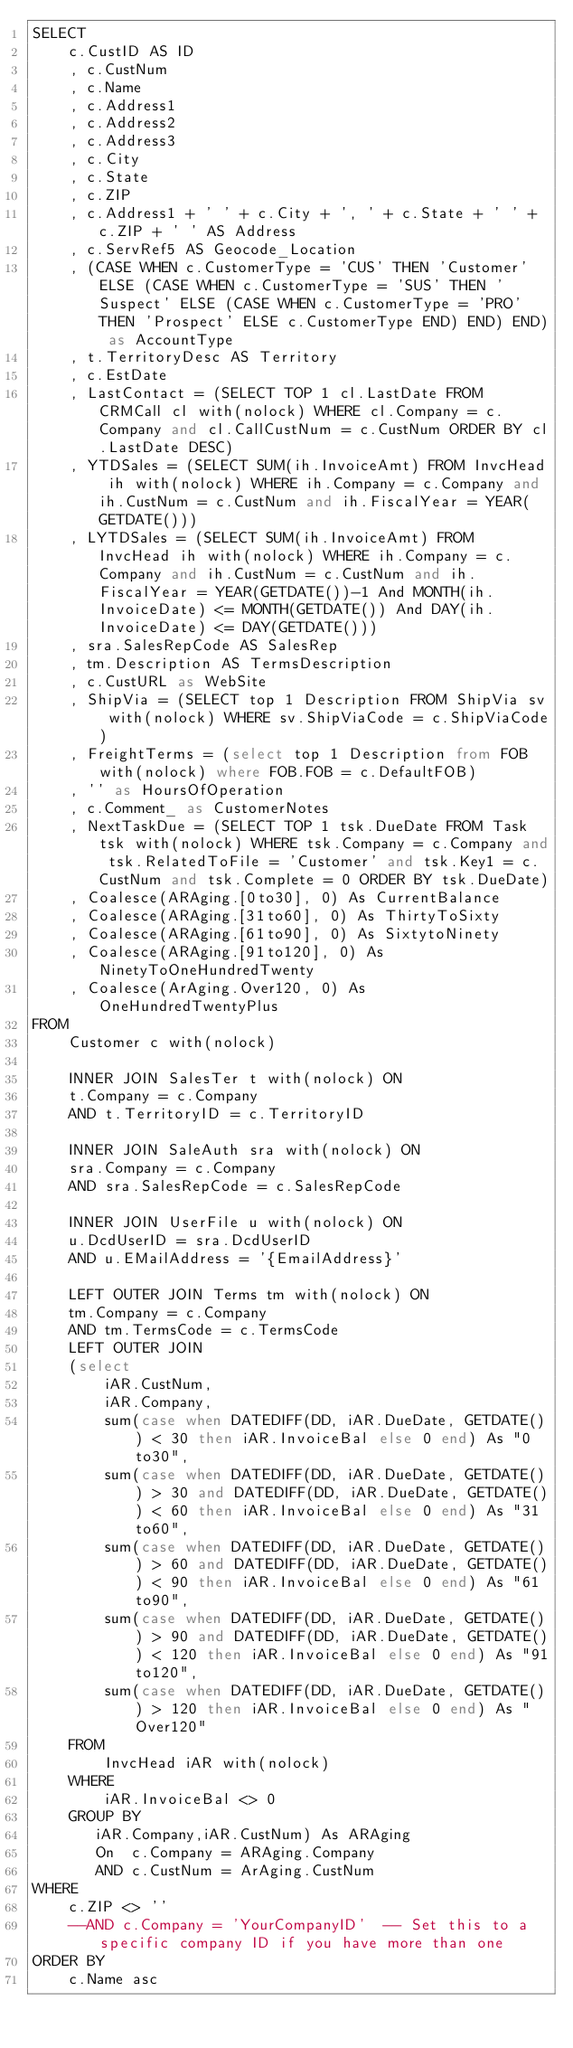<code> <loc_0><loc_0><loc_500><loc_500><_SQL_>SELECT
	c.CustID AS ID
	, c.CustNum
	, c.Name
	, c.Address1
	, c.Address2
	, c.Address3
	, c.City
	, c.State
	, c.ZIP
	, c.Address1 + ' ' + c.City + ', ' + c.State + ' ' + c.ZIP + ' ' AS Address
	, c.ServRef5 AS Geocode_Location
	, (CASE WHEN c.CustomerType = 'CUS' THEN 'Customer' ELSE (CASE WHEN c.CustomerType = 'SUS' THEN 'Suspect' ELSE (CASE WHEN c.CustomerType = 'PRO' THEN 'Prospect' ELSE c.CustomerType END) END) END) as AccountType
	, t.TerritoryDesc AS Territory
	, c.EstDate
	, LastContact = (SELECT TOP 1 cl.LastDate FROM CRMCall cl with(nolock) WHERE cl.Company = c.Company and cl.CallCustNum = c.CustNum ORDER BY cl.LastDate DESC)
	, YTDSales = (SELECT SUM(ih.InvoiceAmt) FROM InvcHead ih with(nolock) WHERE ih.Company = c.Company and ih.CustNum = c.CustNum and ih.FiscalYear = YEAR(GETDATE()))
	, LYTDSales = (SELECT SUM(ih.InvoiceAmt) FROM InvcHead ih with(nolock) WHERE ih.Company = c.Company and ih.CustNum = c.CustNum and ih.FiscalYear = YEAR(GETDATE())-1 And MONTH(ih.InvoiceDate) <= MONTH(GETDATE()) And DAY(ih.InvoiceDate) <= DAY(GETDATE()))
	, sra.SalesRepCode AS SalesRep
	, tm.Description AS TermsDescription
	, c.CustURL as WebSite
	, ShipVia = (SELECT top 1 Description FROM ShipVia sv with(nolock) WHERE sv.ShipViaCode = c.ShipViaCode)
	, FreightTerms = (select top 1 Description from FOB with(nolock) where FOB.FOB = c.DefaultFOB)
	, '' as HoursOfOperation
	, c.Comment_ as CustomerNotes
	, NextTaskDue = (SELECT TOP 1 tsk.DueDate FROM Task tsk with(nolock) WHERE tsk.Company = c.Company and tsk.RelatedToFile = 'Customer' and tsk.Key1 = c.CustNum and tsk.Complete = 0 ORDER BY tsk.DueDate)
	, Coalesce(ARAging.[0to30], 0) As CurrentBalance
	, Coalesce(ARAging.[31to60], 0) As ThirtyToSixty
	, Coalesce(ARAging.[61to90], 0) As SixtytoNinety
	, Coalesce(ARAging.[91to120], 0) As NinetyToOneHundredTwenty
	, Coalesce(ArAging.Over120, 0) As OneHundredTwentyPlus
FROM
	Customer c with(nolock)
	
	INNER JOIN SalesTer t with(nolock) ON
	t.Company = c.Company
	AND t.TerritoryID = c.TerritoryID
	
	INNER JOIN SaleAuth sra with(nolock) ON
	sra.Company = c.Company
	AND sra.SalesRepCode = c.SalesRepCode

	INNER JOIN UserFile u with(nolock) ON
	u.DcdUserID = sra.DcdUserID
	AND u.EMailAddress = '{EmailAddress}'

	LEFT OUTER JOIN Terms tm with(nolock) ON
	tm.Company = c.Company
	AND tm.TermsCode = c.TermsCode
	LEFT OUTER JOIN
	(select 
	    iAR.CustNum,
		iAR.Company,
        sum(case when DATEDIFF(DD, iAR.DueDate, GETDATE()) < 30 then iAR.InvoiceBal else 0 end) As "0to30",
        sum(case when DATEDIFF(DD, iAR.DueDate, GETDATE()) > 30 and DATEDIFF(DD, iAR.DueDate, GETDATE()) < 60 then iAR.InvoiceBal else 0 end) As "31to60",
        sum(case when DATEDIFF(DD, iAR.DueDate, GETDATE()) > 60 and DATEDIFF(DD, iAR.DueDate, GETDATE()) < 90 then iAR.InvoiceBal else 0 end) As "61to90",
        sum(case when DATEDIFF(DD, iAR.DueDate, GETDATE()) > 90 and DATEDIFF(DD, iAR.DueDate, GETDATE()) < 120 then iAR.InvoiceBal else 0 end) As "91to120",       
        sum(case when DATEDIFF(DD, iAR.DueDate, GETDATE()) > 120 then iAR.InvoiceBal else 0 end) As "Over120"
	FROM
		InvcHead iAR with(nolock)
	WHERE 
		iAR.InvoiceBal <> 0
	GROUP BY
	   iAR.Company,iAR.CustNum) As ARAging 
	   On  c.Company = ARAging.Company 
	   AND c.CustNum = ArAging.CustNum
WHERE
	c.ZIP <> ''
	--AND c.Company = 'YourCompanyID'  -- Set this to a specific company ID if you have more than one
ORDER BY
	c.Name asc
</code> 